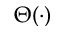<formula> <loc_0><loc_0><loc_500><loc_500>\Theta ( \cdot )</formula> 